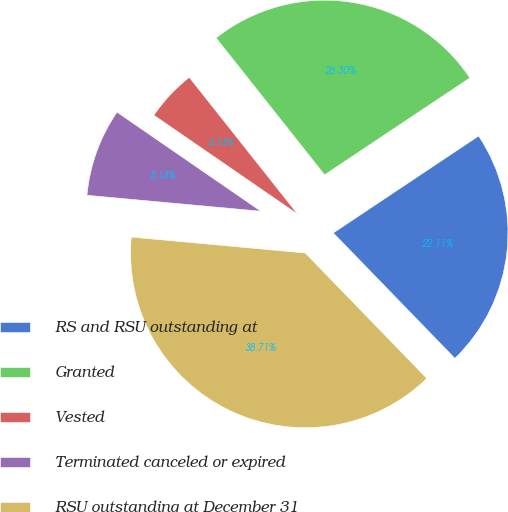Convert chart to OTSL. <chart><loc_0><loc_0><loc_500><loc_500><pie_chart><fcel>RS and RSU outstanding at<fcel>Granted<fcel>Vested<fcel>Terminated canceled or expired<fcel>RSU outstanding at December 31<nl><fcel>22.11%<fcel>26.3%<fcel>4.74%<fcel>8.14%<fcel>38.71%<nl></chart> 